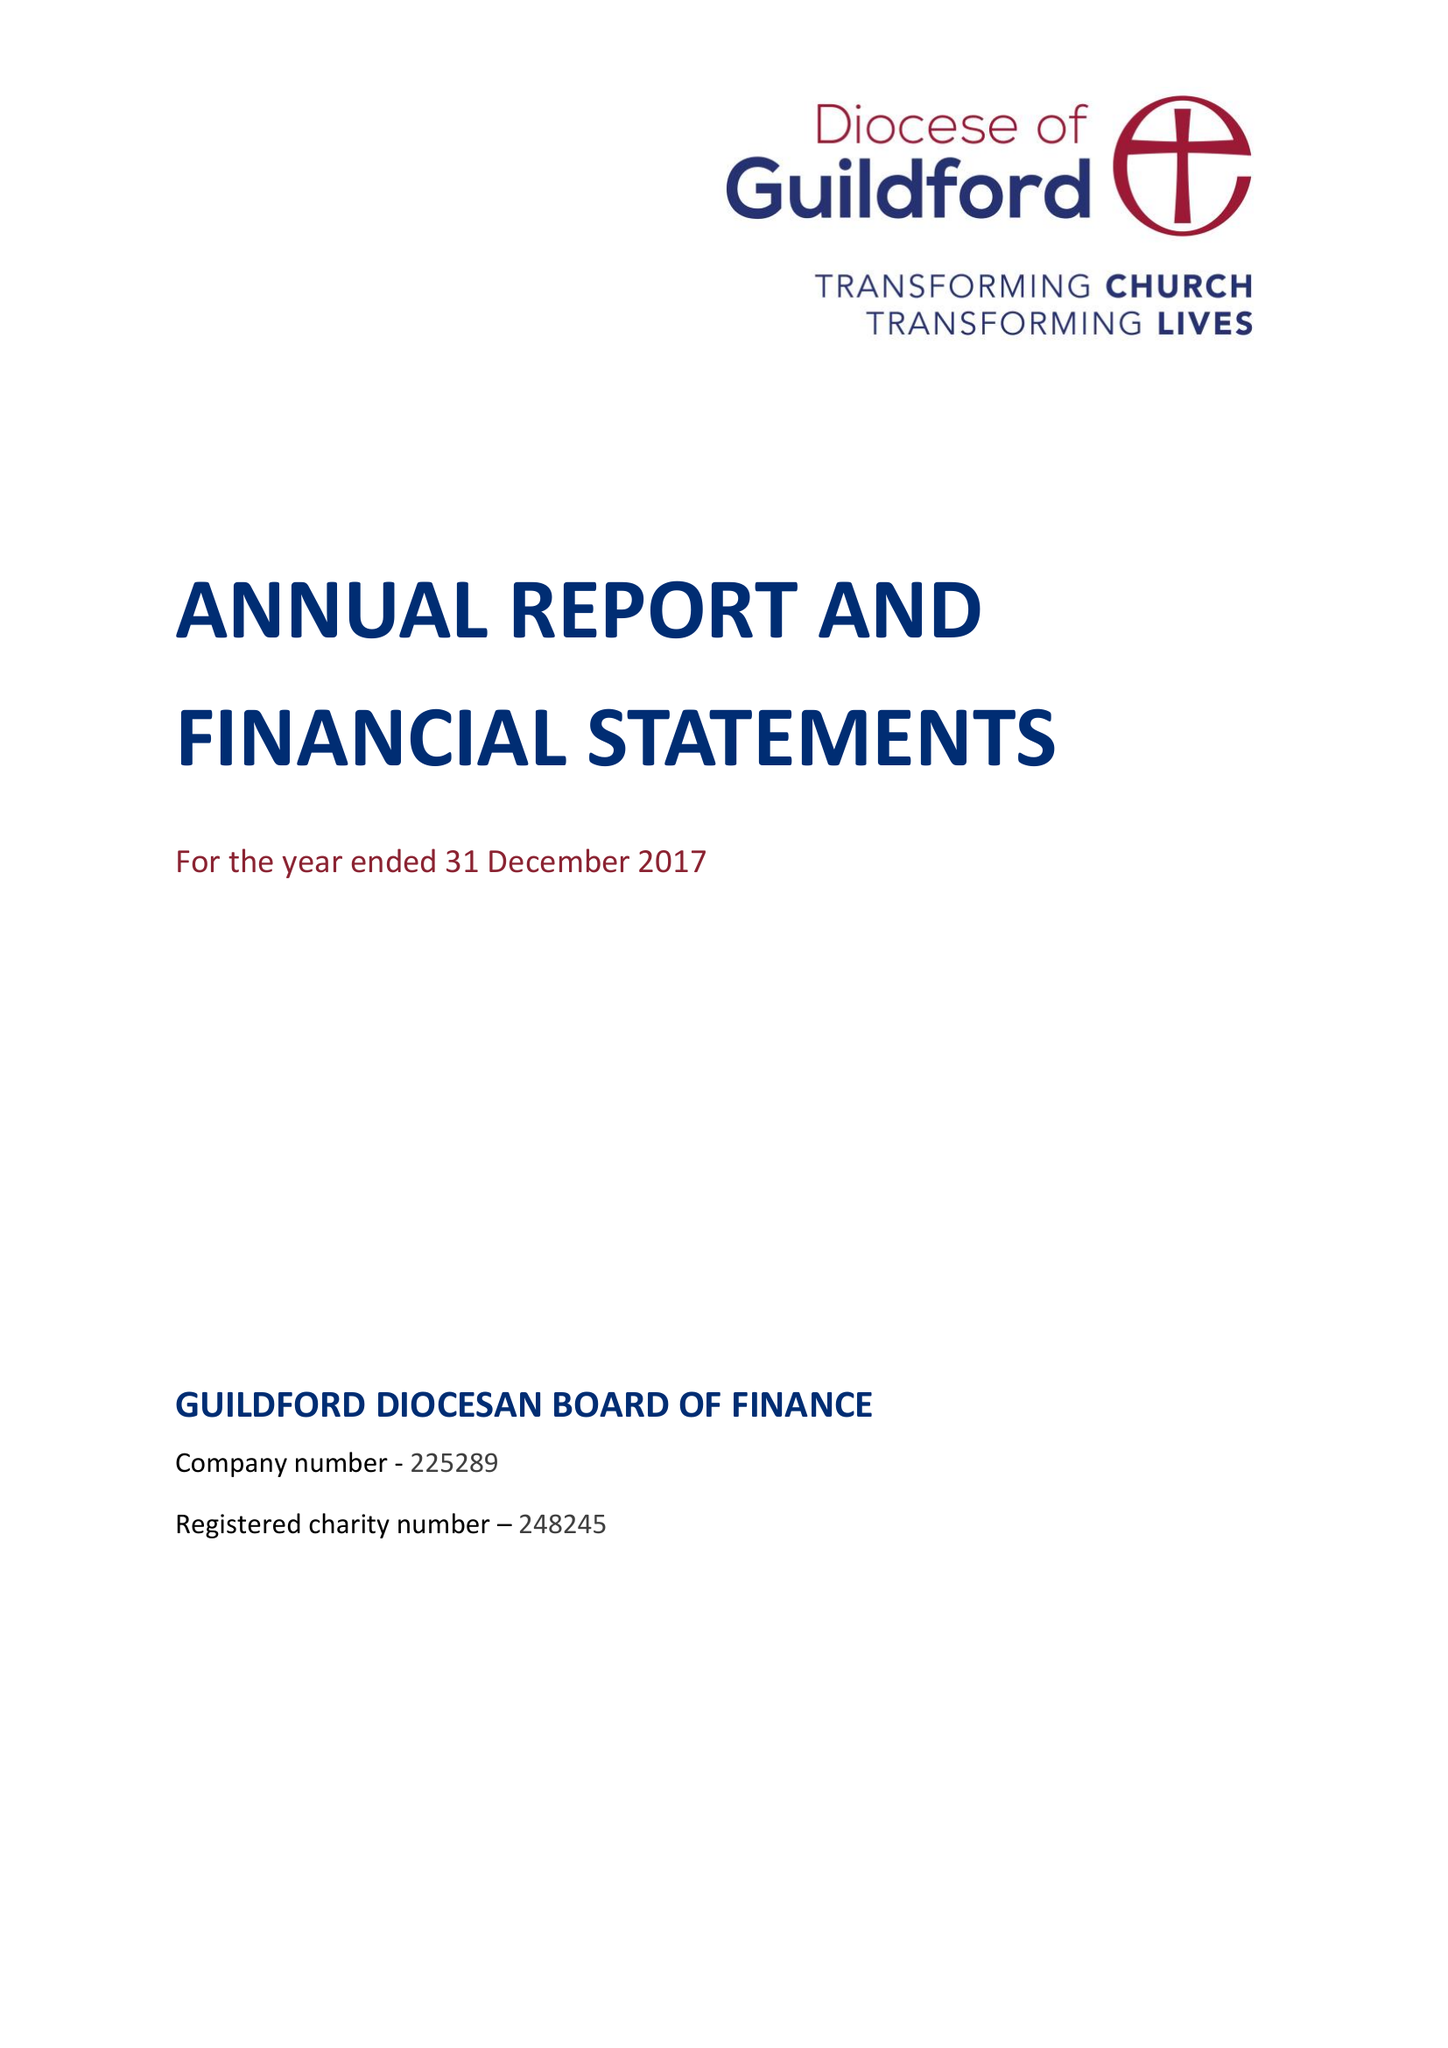What is the value for the address__street_line?
Answer the question using a single word or phrase. 20 ALAN TURING ROAD 